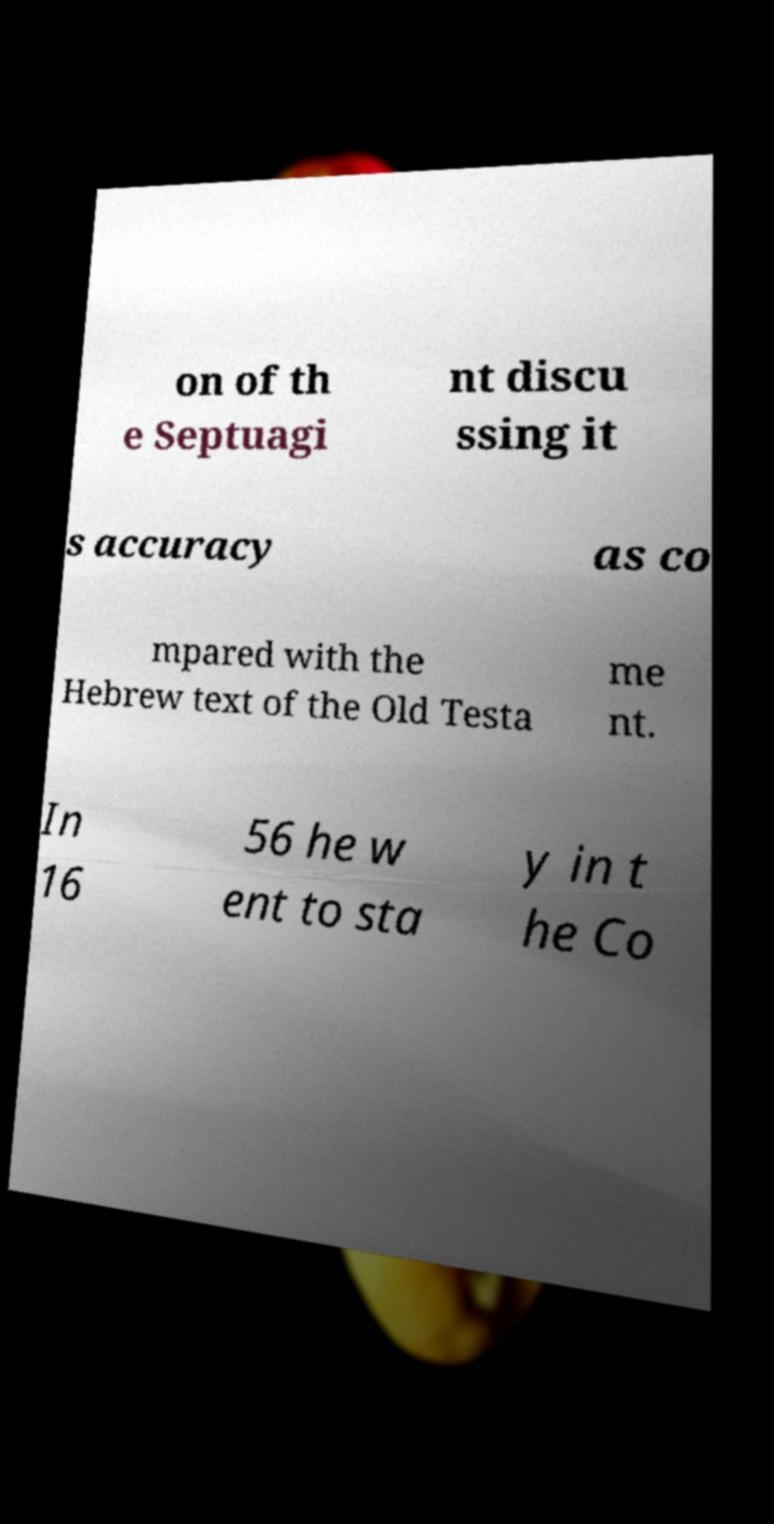There's text embedded in this image that I need extracted. Can you transcribe it verbatim? on of th e Septuagi nt discu ssing it s accuracy as co mpared with the Hebrew text of the Old Testa me nt. In 16 56 he w ent to sta y in t he Co 